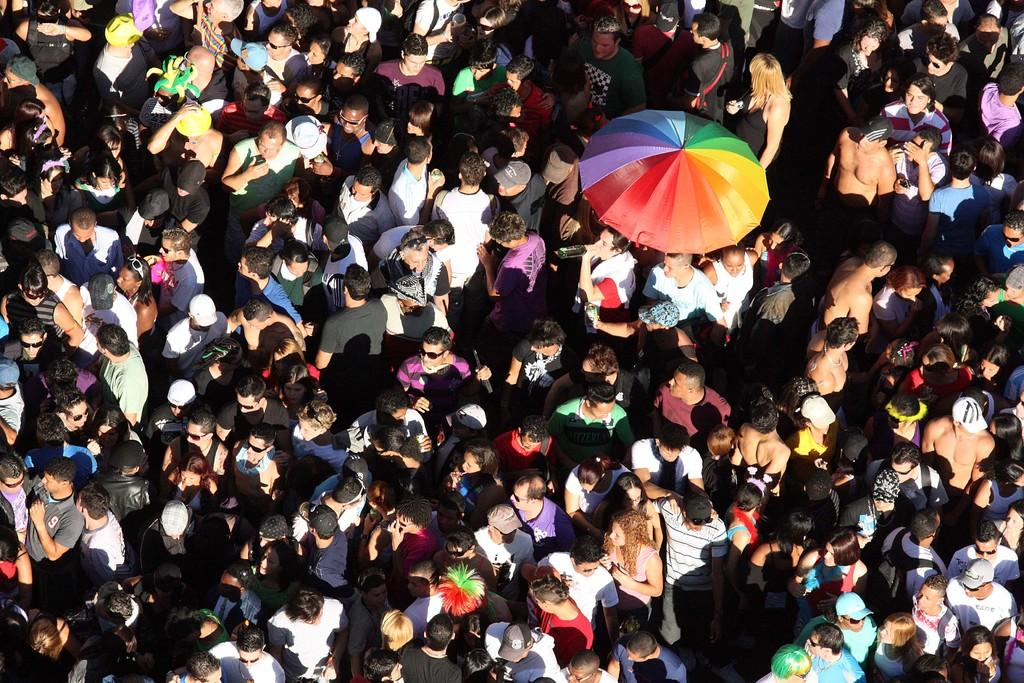Who or what can be seen in the image? There are people in the image. What object is present in the image that might be used for protection from the elements? There is an umbrella in the image. Is there a bridge visible in the image? No, there is no bridge present in the image. Can you provide an example of a carriage in the image? There is no carriage present in the image. 